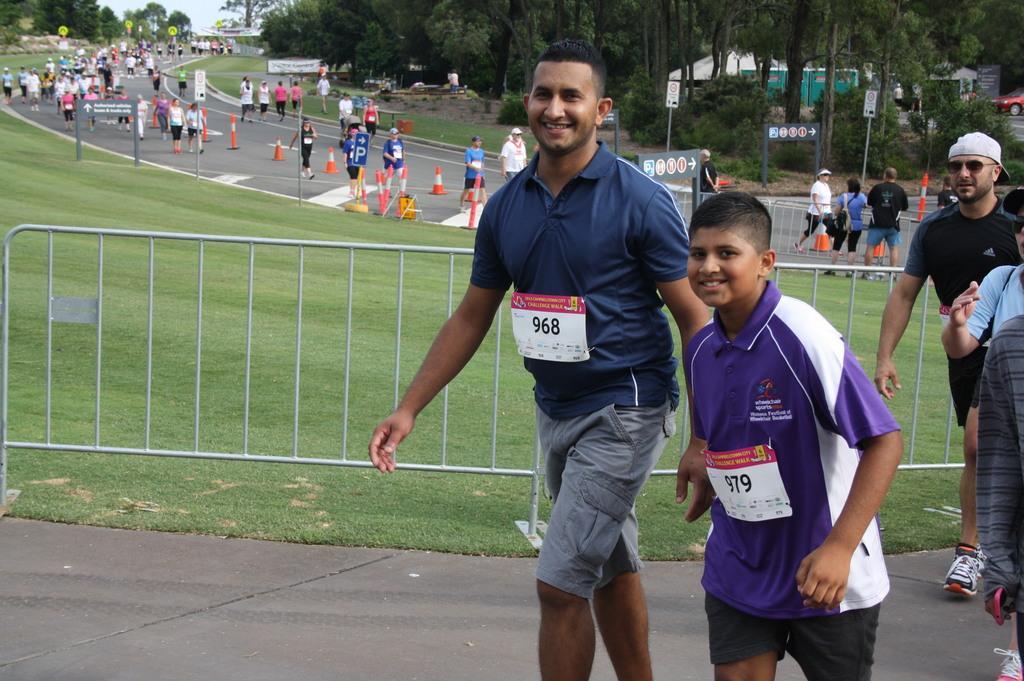Can you describe this image briefly? In this image, there are a few people. We can see the ground with some objects. We can see the fence. We can see some grass, plants and trees. We can see some poles and boards with text written. There are a few sign boards. We can see some vehicles and the sky. 